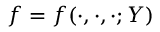Convert formula to latex. <formula><loc_0><loc_0><loc_500><loc_500>f = f ( \cdot , \cdot , \cdot ; Y )</formula> 